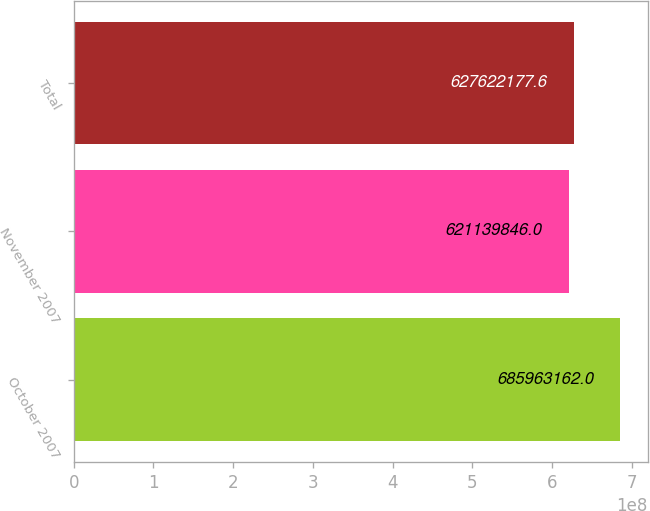Convert chart to OTSL. <chart><loc_0><loc_0><loc_500><loc_500><bar_chart><fcel>October 2007<fcel>November 2007<fcel>Total<nl><fcel>6.85963e+08<fcel>6.2114e+08<fcel>6.27622e+08<nl></chart> 